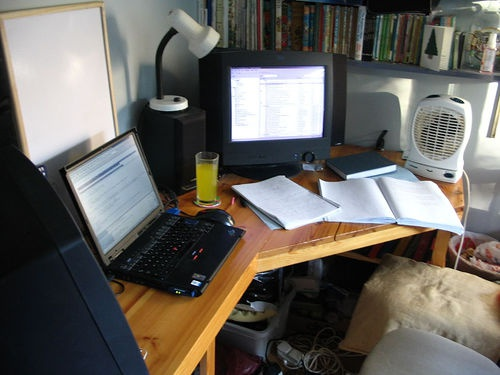Describe the objects in this image and their specific colors. I can see tv in gray, black, navy, and lightgray tones, laptop in gray, black, and darkgray tones, tv in gray, white, and black tones, book in gray, black, and darkgray tones, and chair in gray, tan, and black tones in this image. 